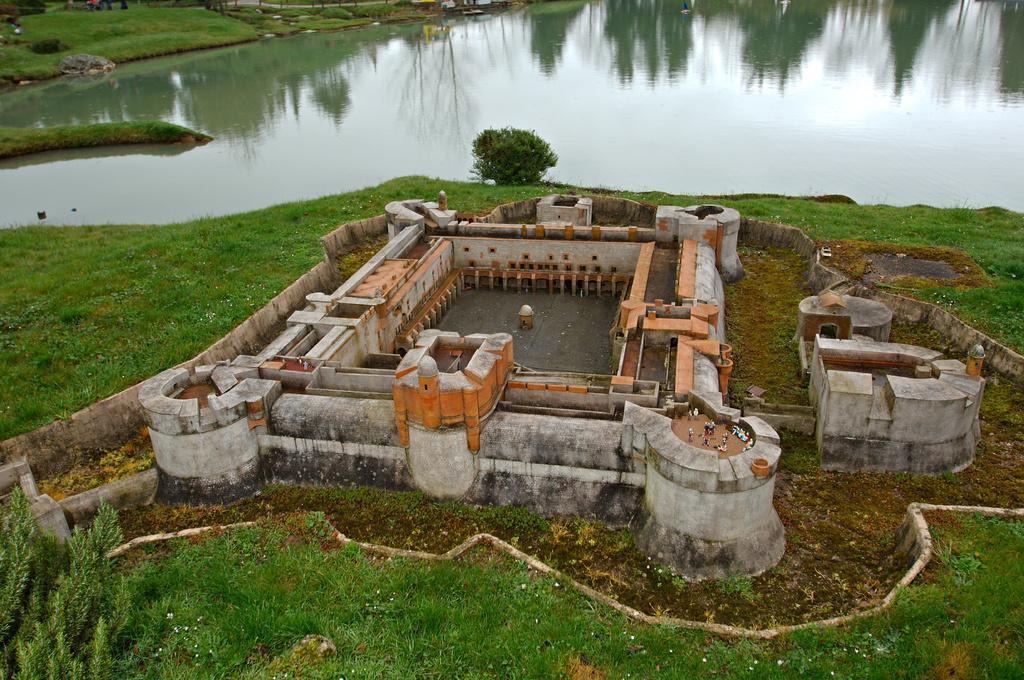Describe this image in one or two sentences. In the picture I can see the castle construction. I can see the green grass at the bottom of the picture. I can see the water pool and trees at the top of the picture. 